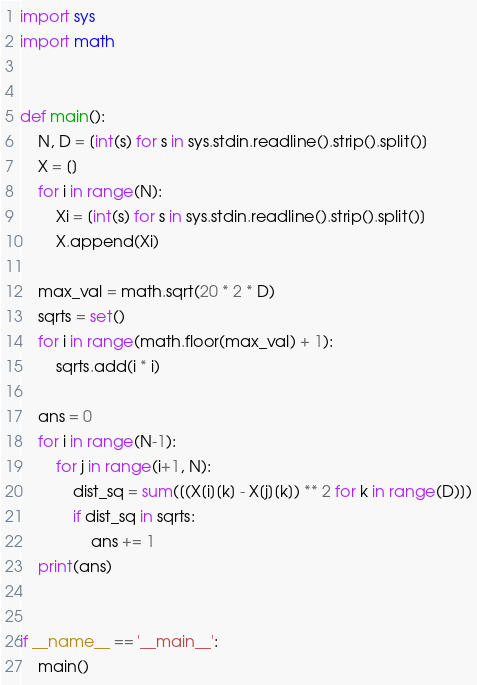<code> <loc_0><loc_0><loc_500><loc_500><_Python_>import sys
import math


def main():
    N, D = [int(s) for s in sys.stdin.readline().strip().split()]
    X = []
    for i in range(N):
        Xi = [int(s) for s in sys.stdin.readline().strip().split()]
        X.append(Xi)

    max_val = math.sqrt(20 * 2 * D)
    sqrts = set()
    for i in range(math.floor(max_val) + 1):
        sqrts.add(i * i)

    ans = 0
    for i in range(N-1):
        for j in range(i+1, N):
            dist_sq = sum([(X[i][k] - X[j][k]) ** 2 for k in range(D)])
            if dist_sq in sqrts:
                ans += 1
    print(ans)


if __name__ == '__main__':
    main()

</code> 